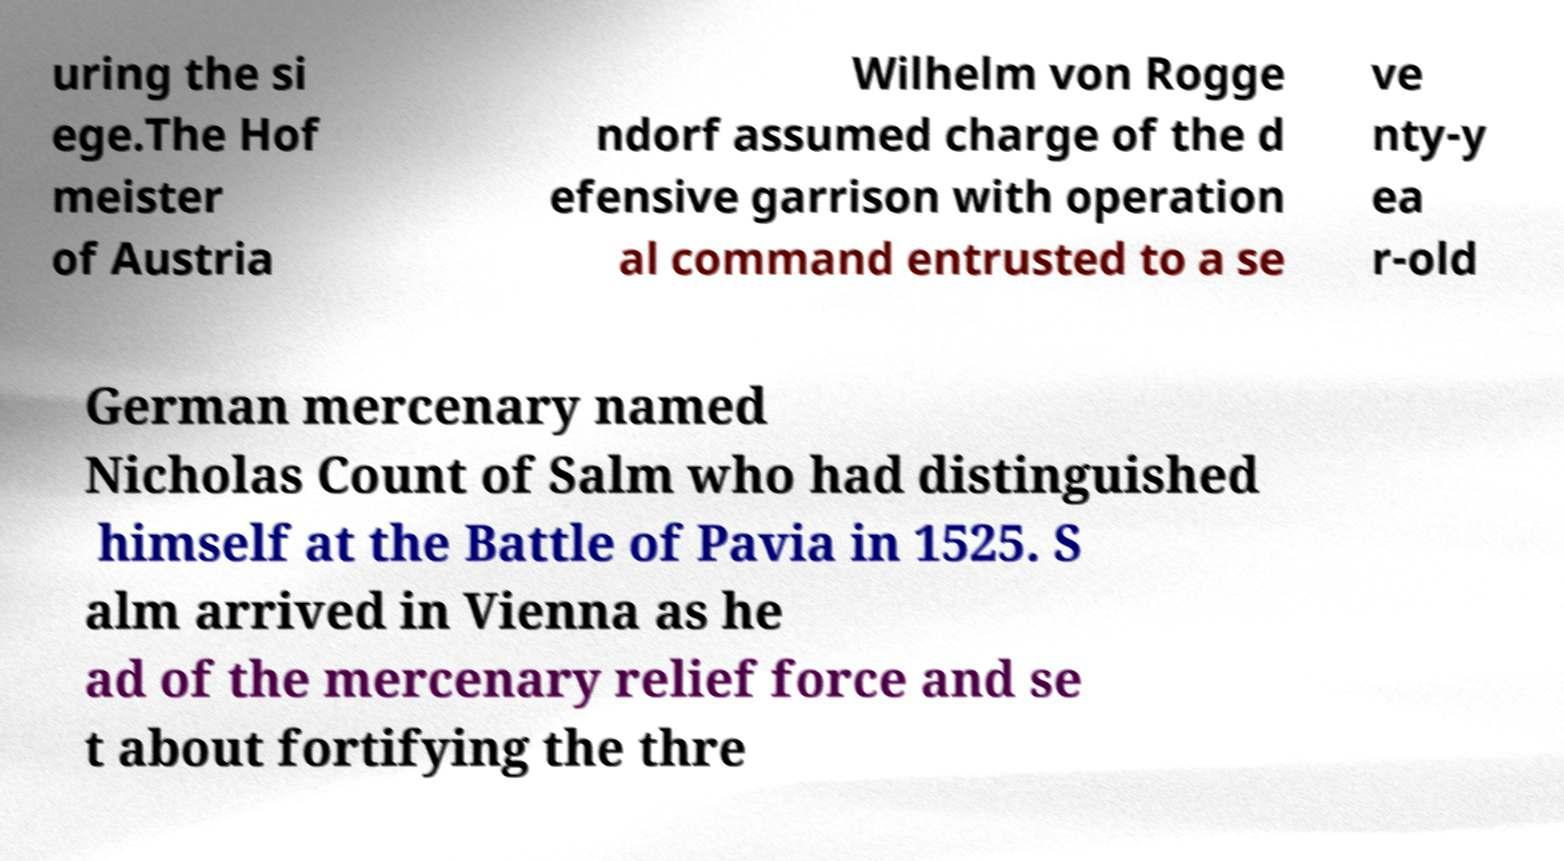Please read and relay the text visible in this image. What does it say? uring the si ege.The Hof meister of Austria Wilhelm von Rogge ndorf assumed charge of the d efensive garrison with operation al command entrusted to a se ve nty-y ea r-old German mercenary named Nicholas Count of Salm who had distinguished himself at the Battle of Pavia in 1525. S alm arrived in Vienna as he ad of the mercenary relief force and se t about fortifying the thre 